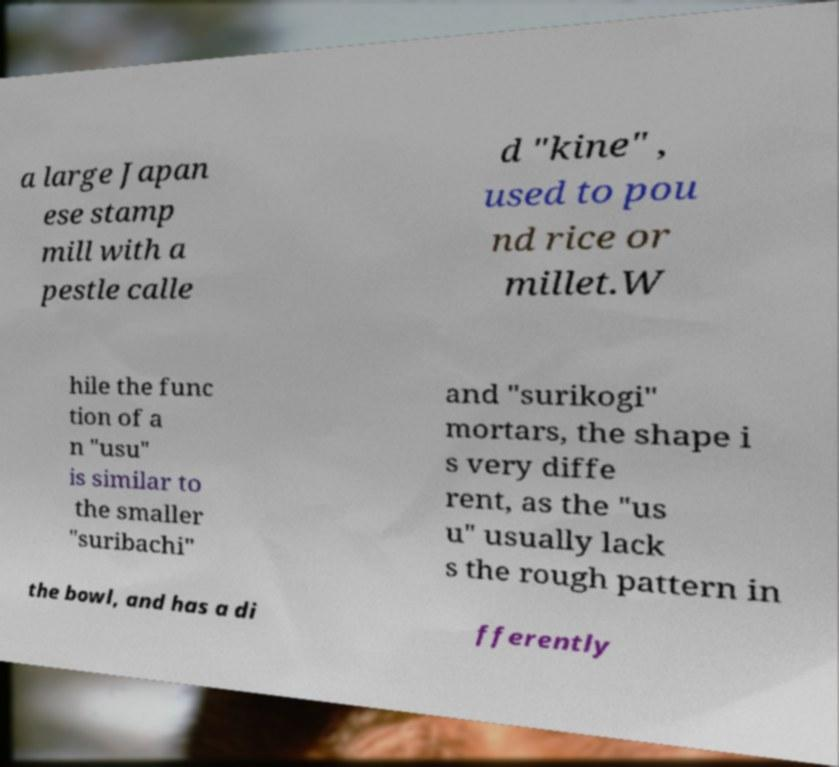Can you accurately transcribe the text from the provided image for me? a large Japan ese stamp mill with a pestle calle d "kine" , used to pou nd rice or millet.W hile the func tion of a n "usu" is similar to the smaller "suribachi" and "surikogi" mortars, the shape i s very diffe rent, as the "us u" usually lack s the rough pattern in the bowl, and has a di fferently 